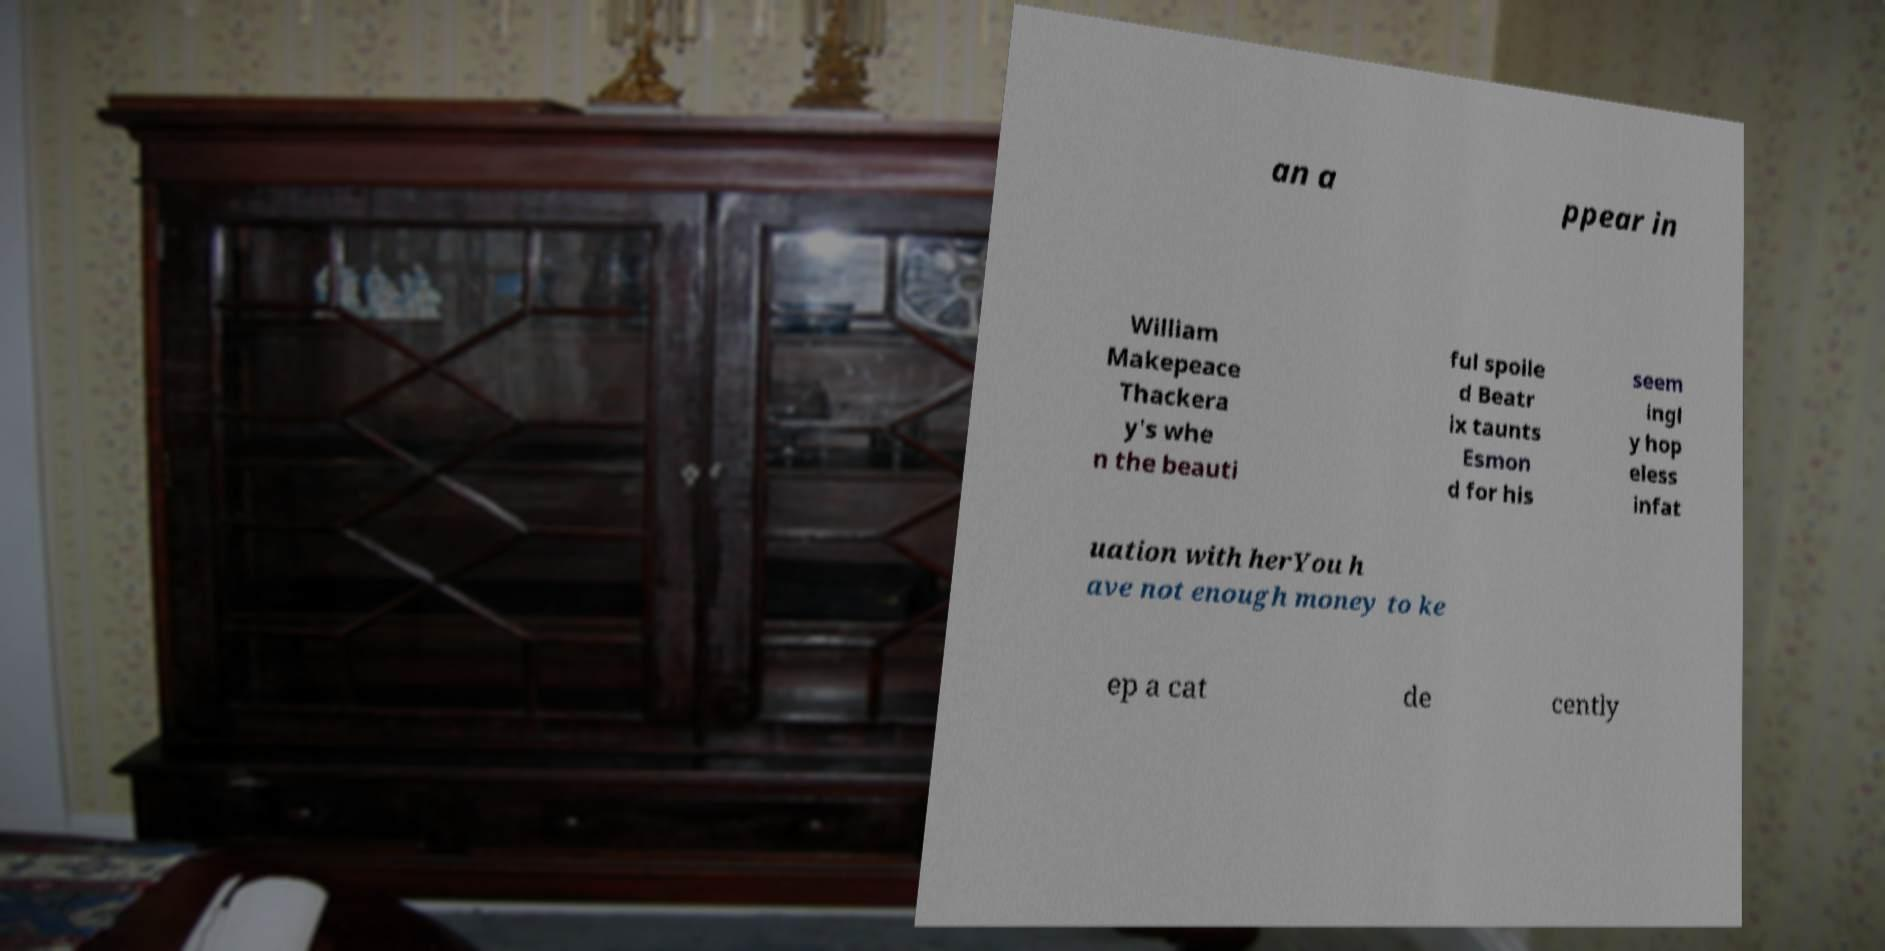For documentation purposes, I need the text within this image transcribed. Could you provide that? an a ppear in William Makepeace Thackera y's whe n the beauti ful spoile d Beatr ix taunts Esmon d for his seem ingl y hop eless infat uation with herYou h ave not enough money to ke ep a cat de cently 